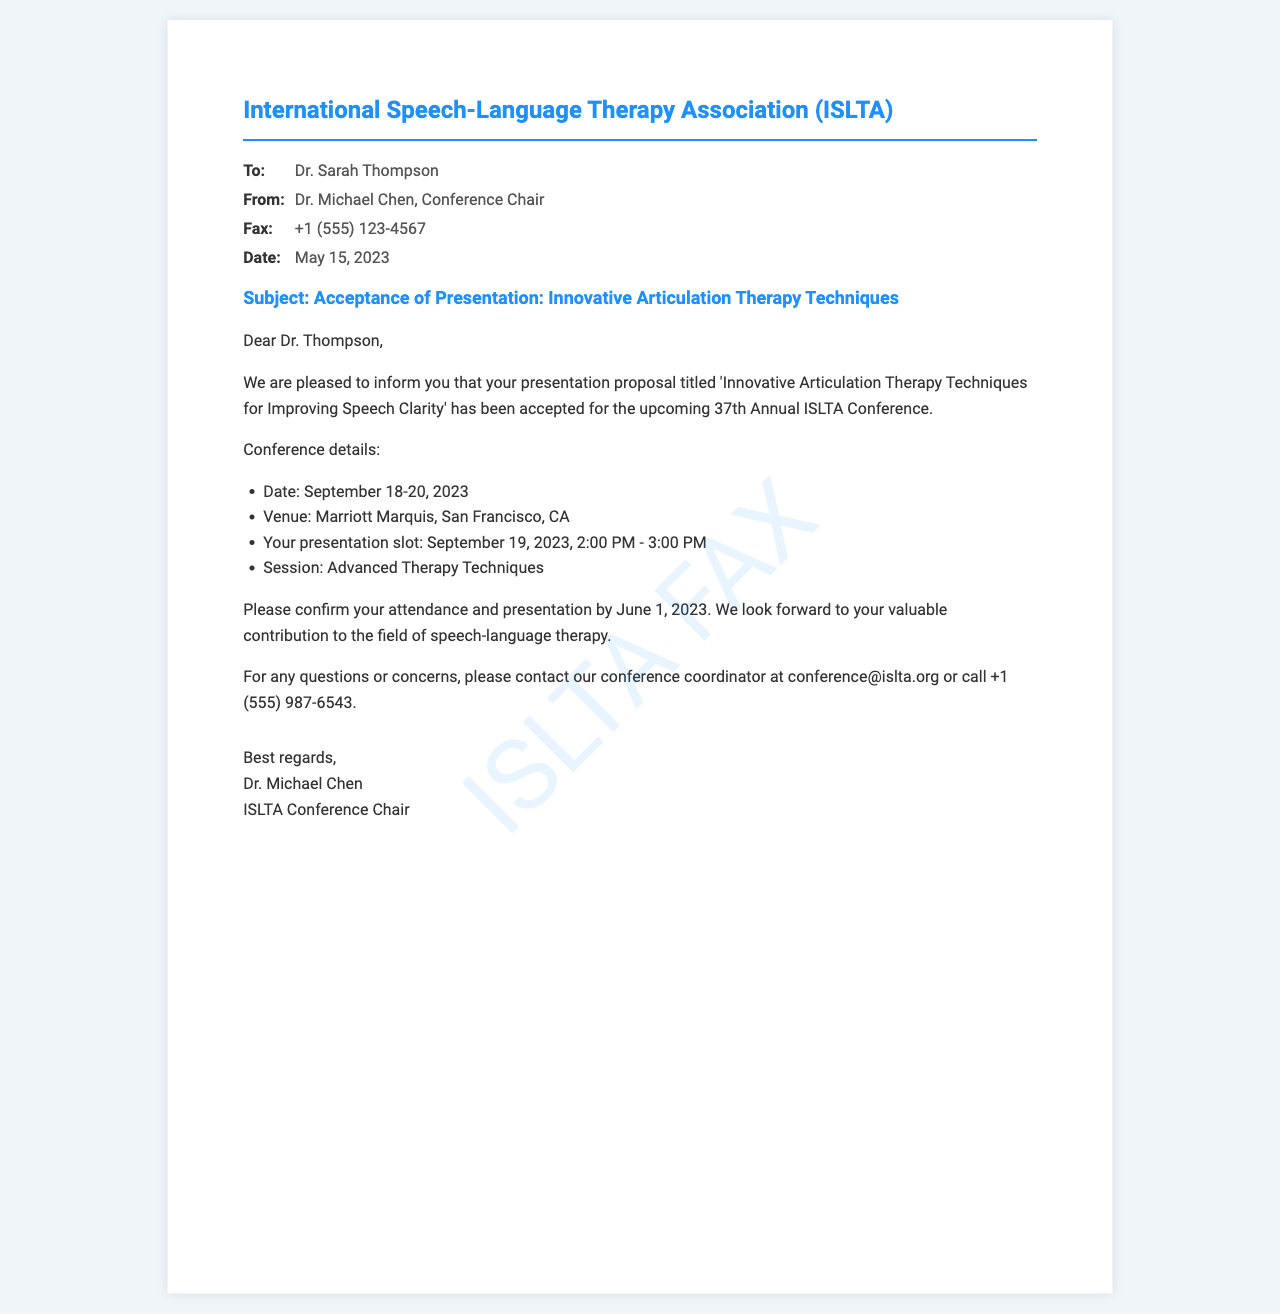What is the title of the presentation? The title of the presentation is specified in the document as 'Innovative Articulation Therapy Techniques for Improving Speech Clarity'.
Answer: Innovative Articulation Therapy Techniques for Improving Speech Clarity Who is the conference chair? The document mentions Dr. Michael Chen as the Conference Chair.
Answer: Dr. Michael Chen What is the date of the conference? The dates of the conference are given as September 18-20, 2023, in the document.
Answer: September 18-20, 2023 When is the presentation slot? The document states that the presentation slot is on September 19, 2023, from 2:00 PM to 3:00 PM.
Answer: September 19, 2023, 2:00 PM - 3:00 PM What is the confirmation deadline for attendance? The document specifies that the confirmation deadline for attendance is June 1, 2023.
Answer: June 1, 2023 What is the name of the association? The fax header indicates that the name of the association is the International Speech-Language Therapy Association (ISLTA).
Answer: International Speech-Language Therapy Association (ISLTA) What type of session will the presentation be part of? The document mentions that the presentation will be part of the 'Advanced Therapy Techniques' session.
Answer: Advanced Therapy Techniques What contact method is provided for questions? The document provides an email address for contacting the conference coordinator for questions at conference@islta.org.
Answer: conference@islta.org 